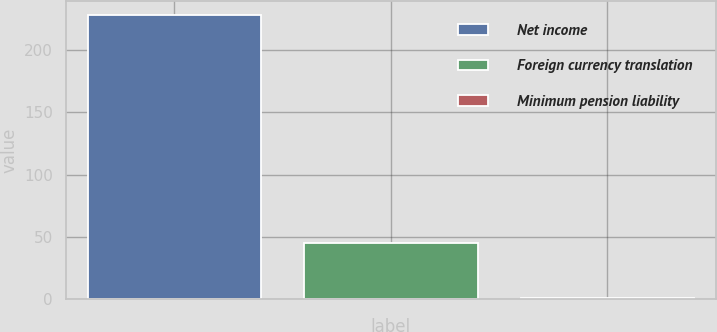<chart> <loc_0><loc_0><loc_500><loc_500><bar_chart><fcel>Net income<fcel>Foreign currency translation<fcel>Minimum pension liability<nl><fcel>228<fcel>45.5<fcel>1.4<nl></chart> 